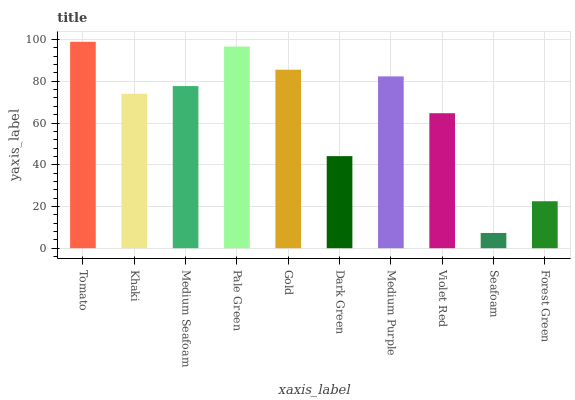Is Seafoam the minimum?
Answer yes or no. Yes. Is Tomato the maximum?
Answer yes or no. Yes. Is Khaki the minimum?
Answer yes or no. No. Is Khaki the maximum?
Answer yes or no. No. Is Tomato greater than Khaki?
Answer yes or no. Yes. Is Khaki less than Tomato?
Answer yes or no. Yes. Is Khaki greater than Tomato?
Answer yes or no. No. Is Tomato less than Khaki?
Answer yes or no. No. Is Medium Seafoam the high median?
Answer yes or no. Yes. Is Khaki the low median?
Answer yes or no. Yes. Is Pale Green the high median?
Answer yes or no. No. Is Medium Seafoam the low median?
Answer yes or no. No. 